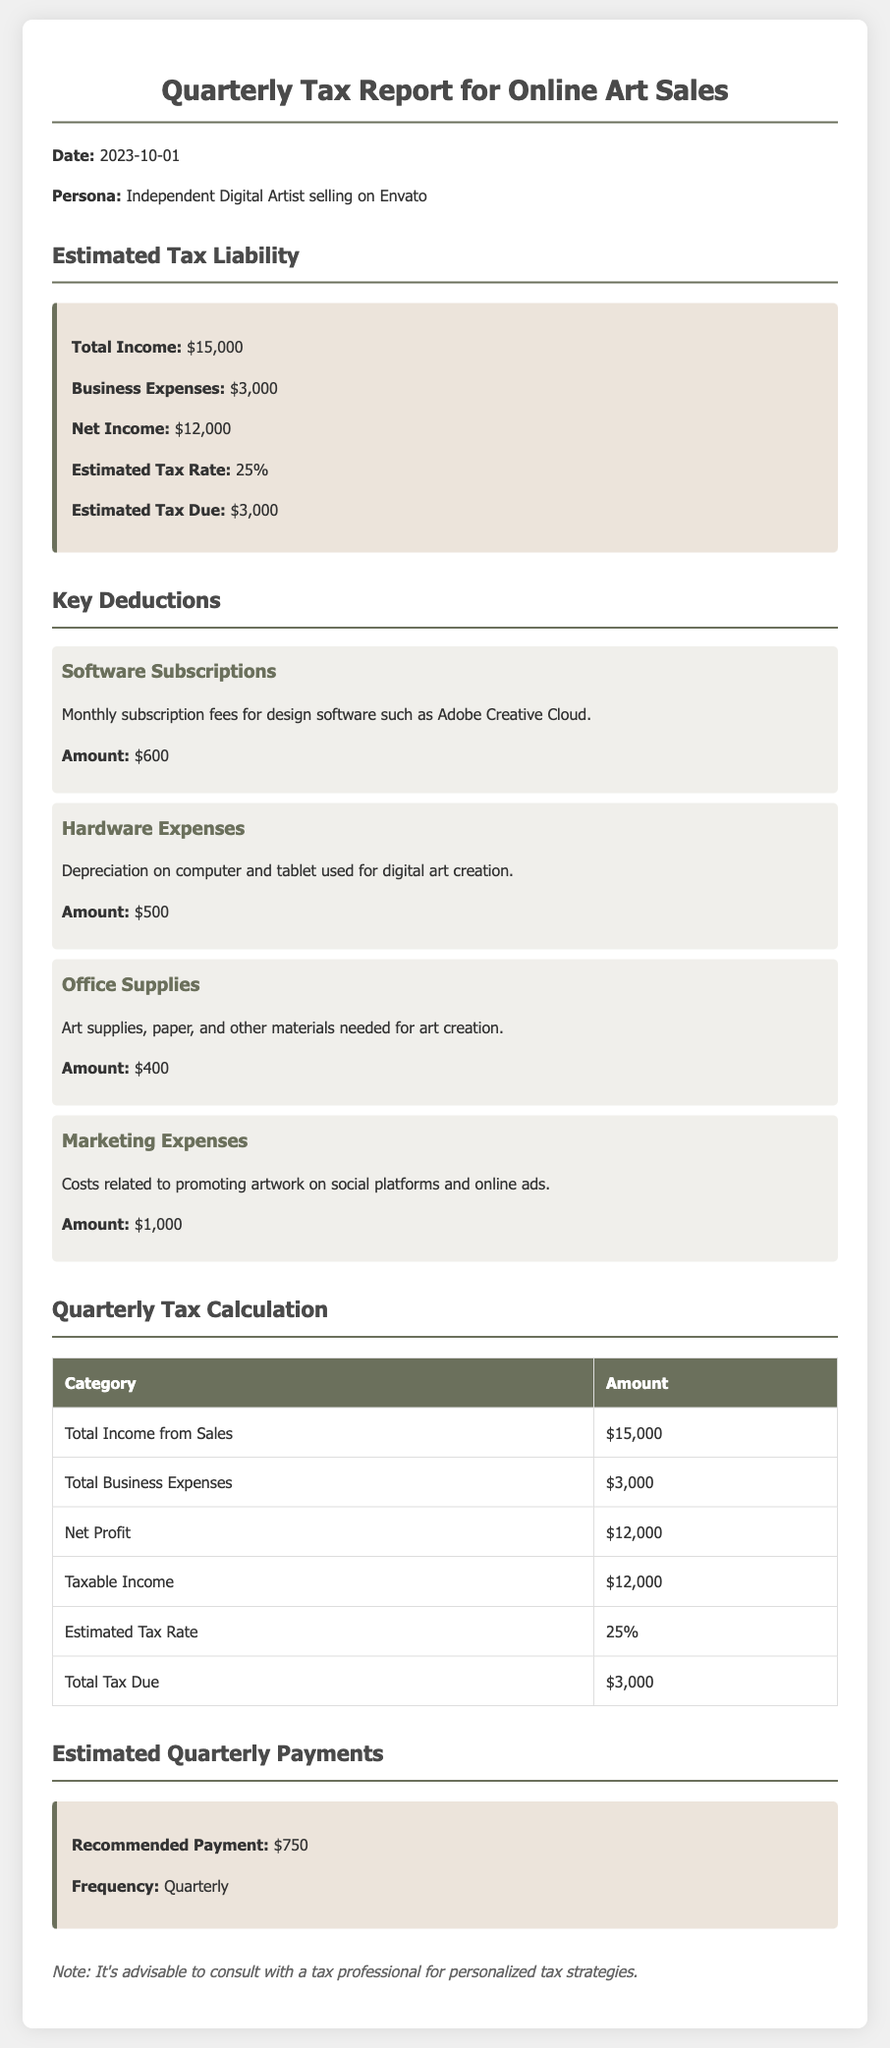what is the total income? The total income from online art sales in the document is specified directly as $15,000.
Answer: $15,000 what are the total business expenses? The document states the total business expenses incurred during the quarter, which amounts to $3,000.
Answer: $3,000 what is the estimated tax rate? The estimated tax rate applied in this financial report is indicated to be 25%.
Answer: 25% what is the total tax due? The total tax liability calculated in the document is $3,000 based on the net income.
Answer: $3,000 what is the amount for software subscriptions? The amount listed for software subscriptions is specified as $600.
Answer: $600 how much is recommended for quarterly payment? The recommended payment amount for taxes each quarter is noted to be $750.
Answer: $750 what is the net income after expenses? The document calculates the net income as total income minus business expenses, which equals $12,000.
Answer: $12,000 what expenses are included in the deductions section? The deductions section lists software subscriptions, hardware expenses, office supplies, and marketing expenses.
Answer: Software subscriptions, hardware expenses, office supplies, marketing expenses how much are marketing expenses? The amount allocated for marketing expenses is $1,000 according to the document.
Answer: $1,000 